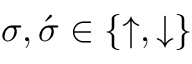Convert formula to latex. <formula><loc_0><loc_0><loc_500><loc_500>\sigma , \acute { \sigma } \in \{ \uparrow , \downarrow \}</formula> 